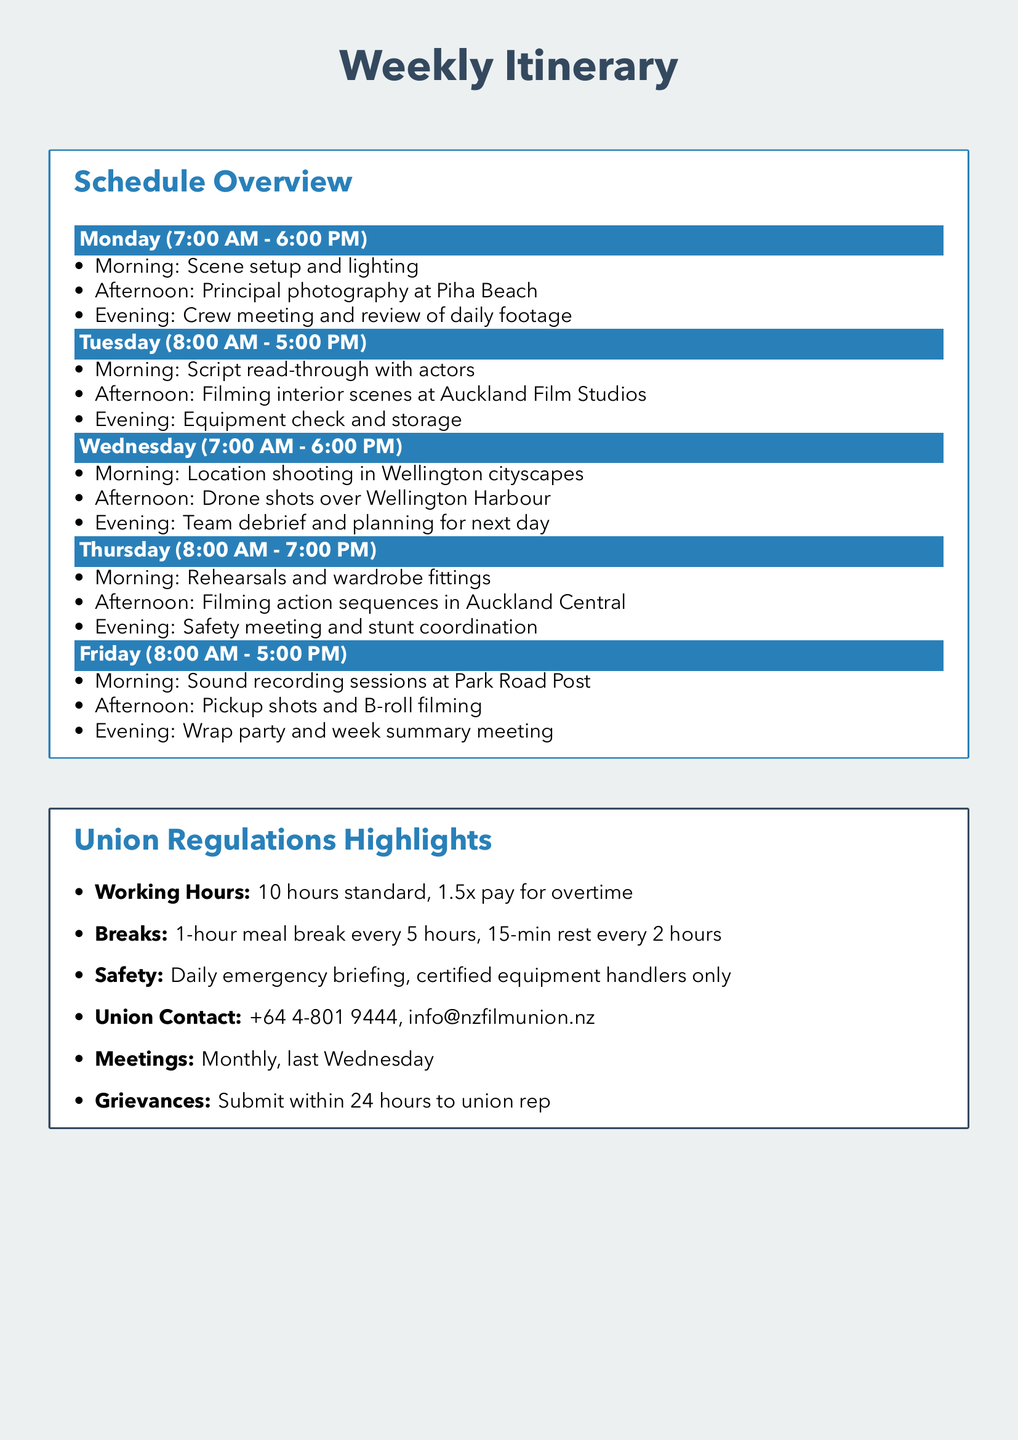What time does filming start on Monday? The schedule states that filming starts at 7:00 AM on Monday.
Answer: 7:00 AM What is the location for the principal photography on Monday? The document specifies that principal photography takes place at Piha Beach on Monday.
Answer: Piha Beach How long is the meal break according to union regulations? The document indicates that there is a 1-hour meal break every 5 hours.
Answer: 1-hour What is the standard working hours limit set by the union? The union regulations highlight that the standard working hours are 10 hours.
Answer: 10 hours On which day is the safety meeting scheduled? The itinerary shows that the safety meeting takes place on Thursday evening.
Answer: Thursday What is the contact number for the union? The document provides the union contact number as +64 4-801 9444.
Answer: +64 4-801 9444 When are the monthly union meetings held? According to the union regulations, monthly meetings are held on the last Wednesday of each month.
Answer: Last Wednesday What activities are scheduled for Tuesday afternoon? The itinerary states that Tuesday afternoon is reserved for filming interior scenes at Auckland Film Studios.
Answer: Filming interior scenes at Auckland Film Studios 